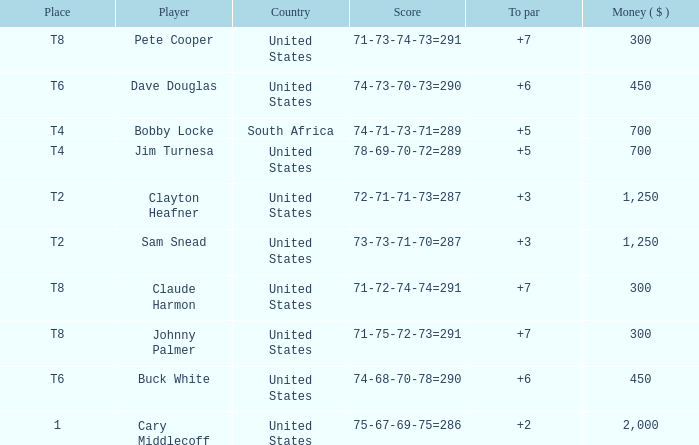What is the Johnny Palmer with a To larger than 6 Money sum? 300.0. 